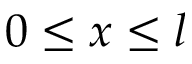<formula> <loc_0><loc_0><loc_500><loc_500>0 \leq x \leq l</formula> 